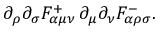Convert formula to latex. <formula><loc_0><loc_0><loc_500><loc_500>\partial _ { \rho } \partial _ { \sigma } F _ { \alpha \mu \nu } ^ { + } \, \partial _ { \mu } \partial _ { \nu } F _ { \alpha \rho \sigma } ^ { - } .</formula> 